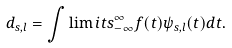Convert formula to latex. <formula><loc_0><loc_0><loc_500><loc_500>d _ { s , l } = \int \lim i t s _ { - \infty } ^ { \infty } f ( t ) \psi _ { s , l } ( t ) d t .</formula> 